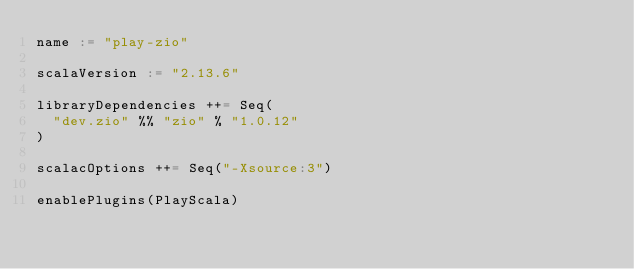<code> <loc_0><loc_0><loc_500><loc_500><_Scala_>name := "play-zio"

scalaVersion := "2.13.6"

libraryDependencies ++= Seq(
  "dev.zio" %% "zio" % "1.0.12"
)

scalacOptions ++= Seq("-Xsource:3")

enablePlugins(PlayScala)
</code> 